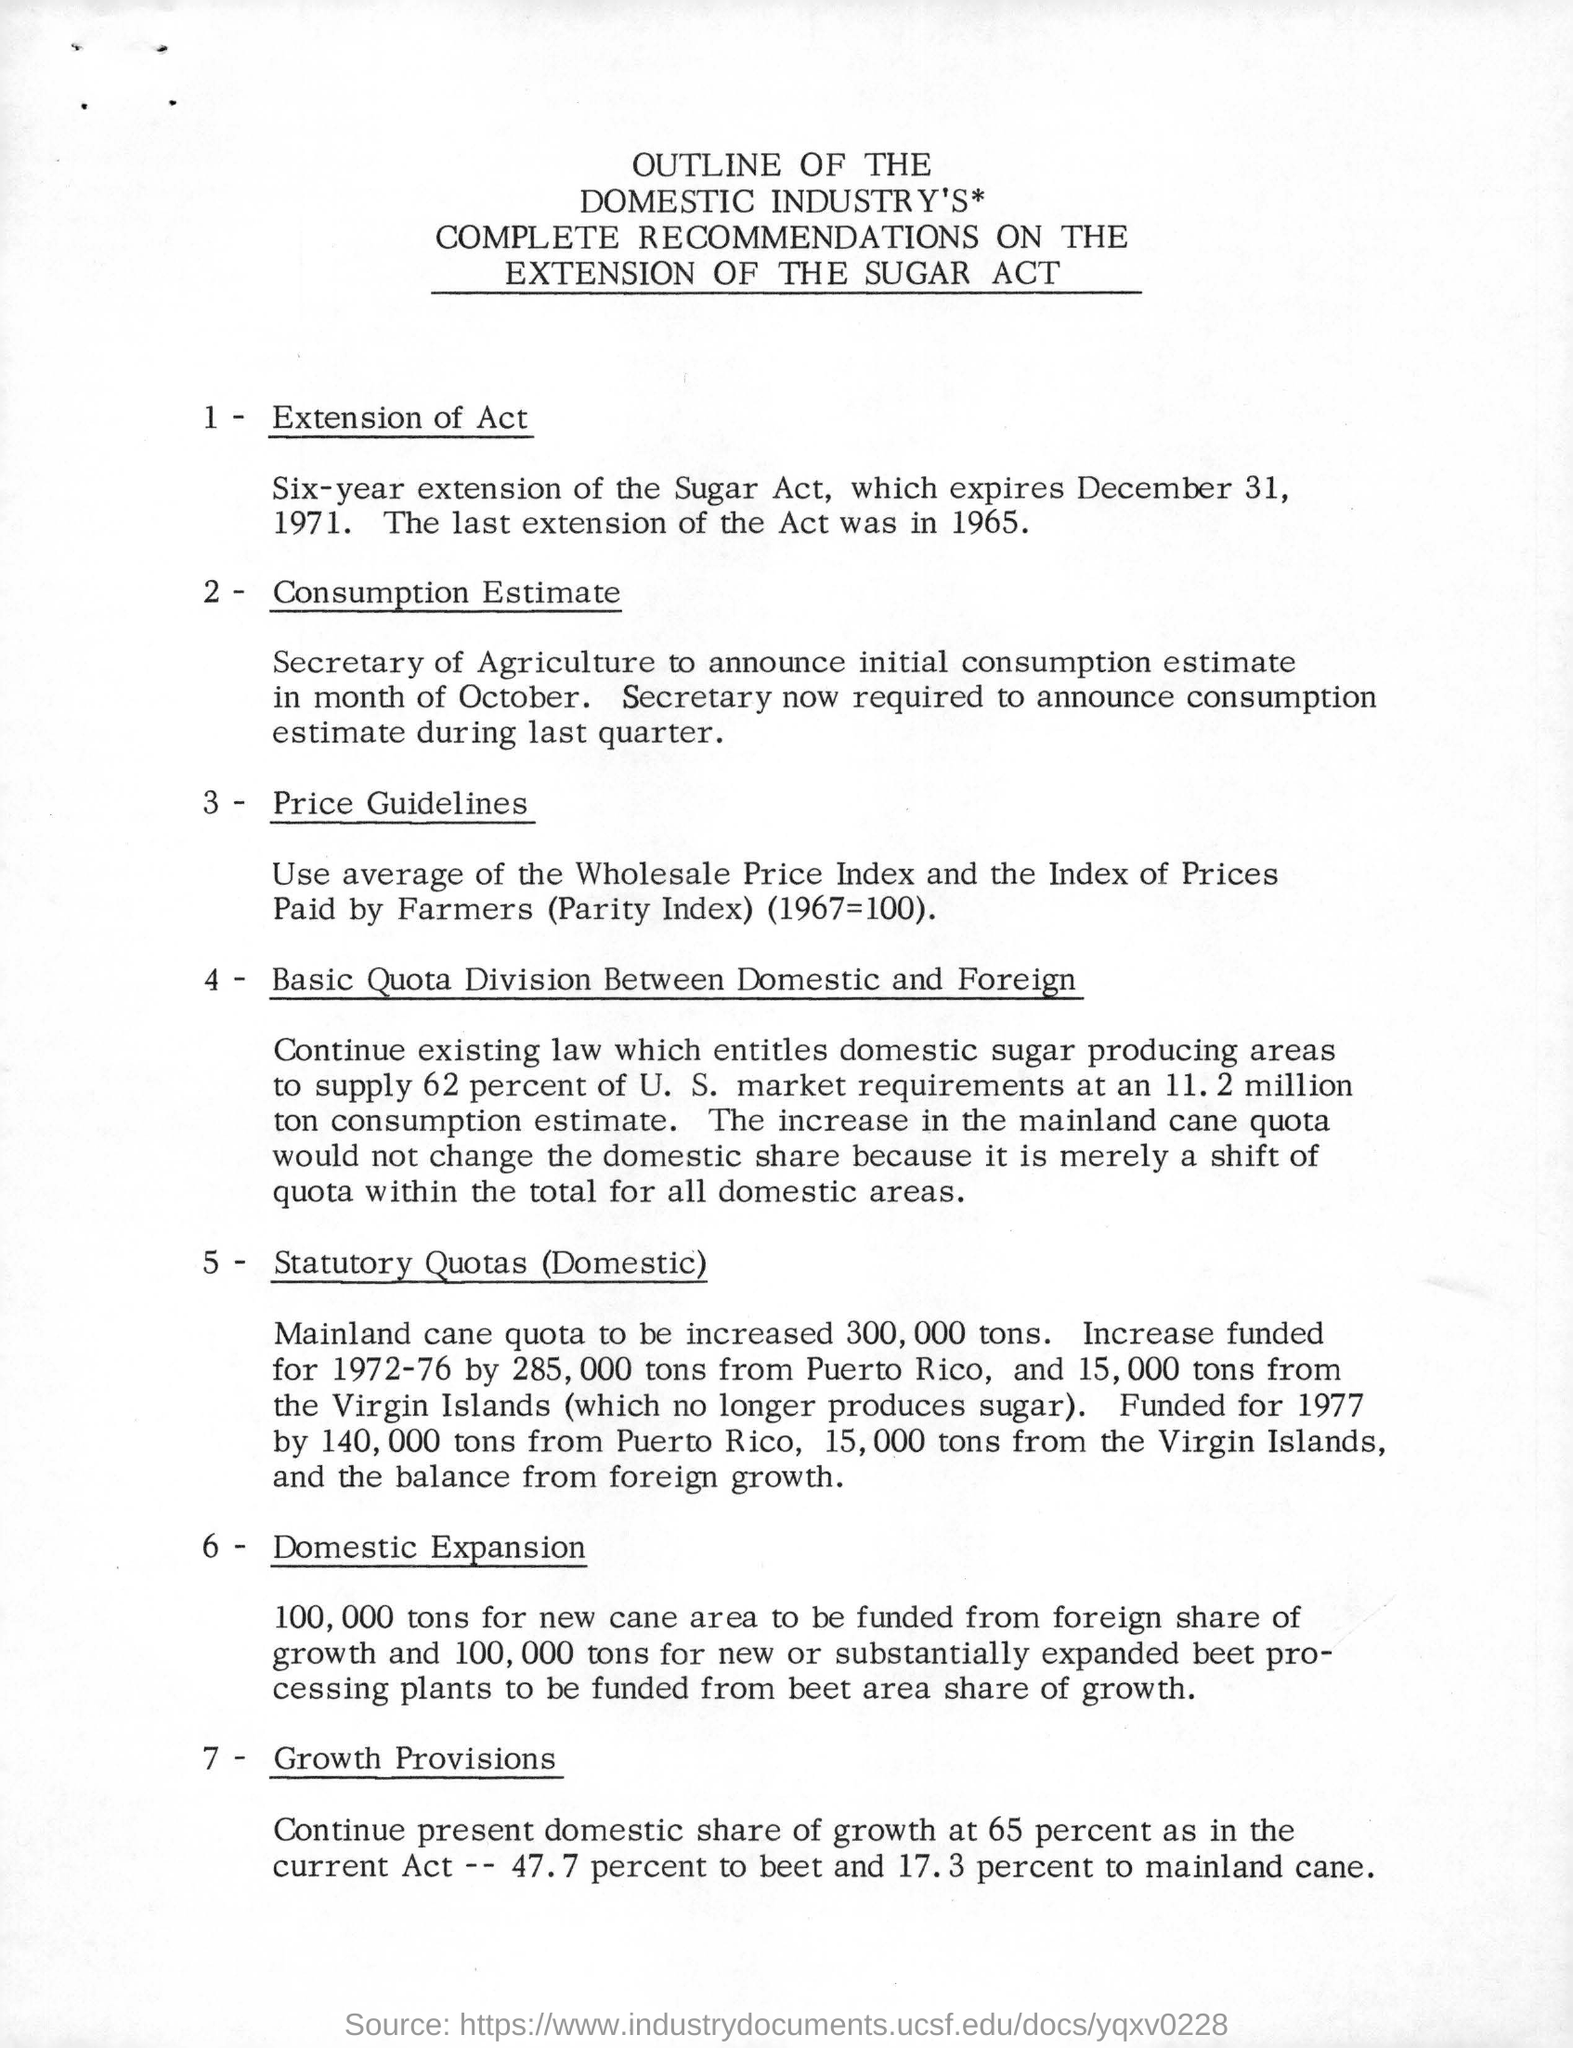When was the last extension of the Sugar Act?
Provide a short and direct response. 1965. When does the sugar act expire?
Give a very brief answer. December 31, 1971. 